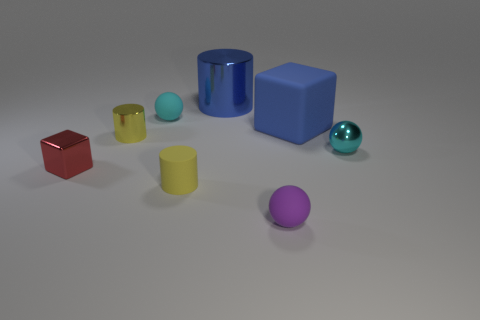Are there any red objects behind the tiny metallic object that is behind the cyan shiny ball?
Your answer should be compact. No. Are there fewer big metal things that are right of the rubber block than big blue things in front of the blue cylinder?
Ensure brevity in your answer.  Yes. There is a blue object that is in front of the blue object to the left of the matte sphere in front of the small cyan matte ball; what size is it?
Your answer should be compact. Large. Does the cyan object that is in front of the blue matte block have the same size as the red cube?
Your answer should be compact. Yes. How many other things are made of the same material as the red block?
Provide a short and direct response. 3. Is the number of blue blocks greater than the number of small cyan balls?
Give a very brief answer. No. What material is the yellow thing that is in front of the tiny red object that is left of the small yellow cylinder to the right of the yellow shiny cylinder?
Make the answer very short. Rubber. Does the rubber cylinder have the same color as the small metallic cylinder?
Your answer should be very brief. Yes. Are there any other spheres that have the same color as the shiny sphere?
Your answer should be compact. Yes. There is another blue object that is the same size as the blue metal thing; what is its shape?
Give a very brief answer. Cube. 